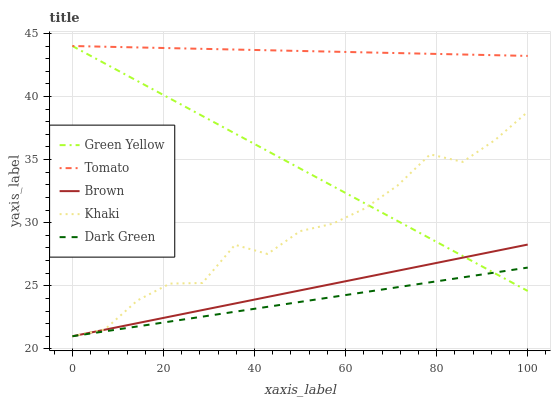Does Dark Green have the minimum area under the curve?
Answer yes or no. Yes. Does Tomato have the maximum area under the curve?
Answer yes or no. Yes. Does Brown have the minimum area under the curve?
Answer yes or no. No. Does Brown have the maximum area under the curve?
Answer yes or no. No. Is Tomato the smoothest?
Answer yes or no. Yes. Is Khaki the roughest?
Answer yes or no. Yes. Is Brown the smoothest?
Answer yes or no. No. Is Brown the roughest?
Answer yes or no. No. Does Brown have the lowest value?
Answer yes or no. Yes. Does Green Yellow have the lowest value?
Answer yes or no. No. Does Green Yellow have the highest value?
Answer yes or no. Yes. Does Brown have the highest value?
Answer yes or no. No. Is Dark Green less than Tomato?
Answer yes or no. Yes. Is Tomato greater than Khaki?
Answer yes or no. Yes. Does Brown intersect Green Yellow?
Answer yes or no. Yes. Is Brown less than Green Yellow?
Answer yes or no. No. Is Brown greater than Green Yellow?
Answer yes or no. No. Does Dark Green intersect Tomato?
Answer yes or no. No. 